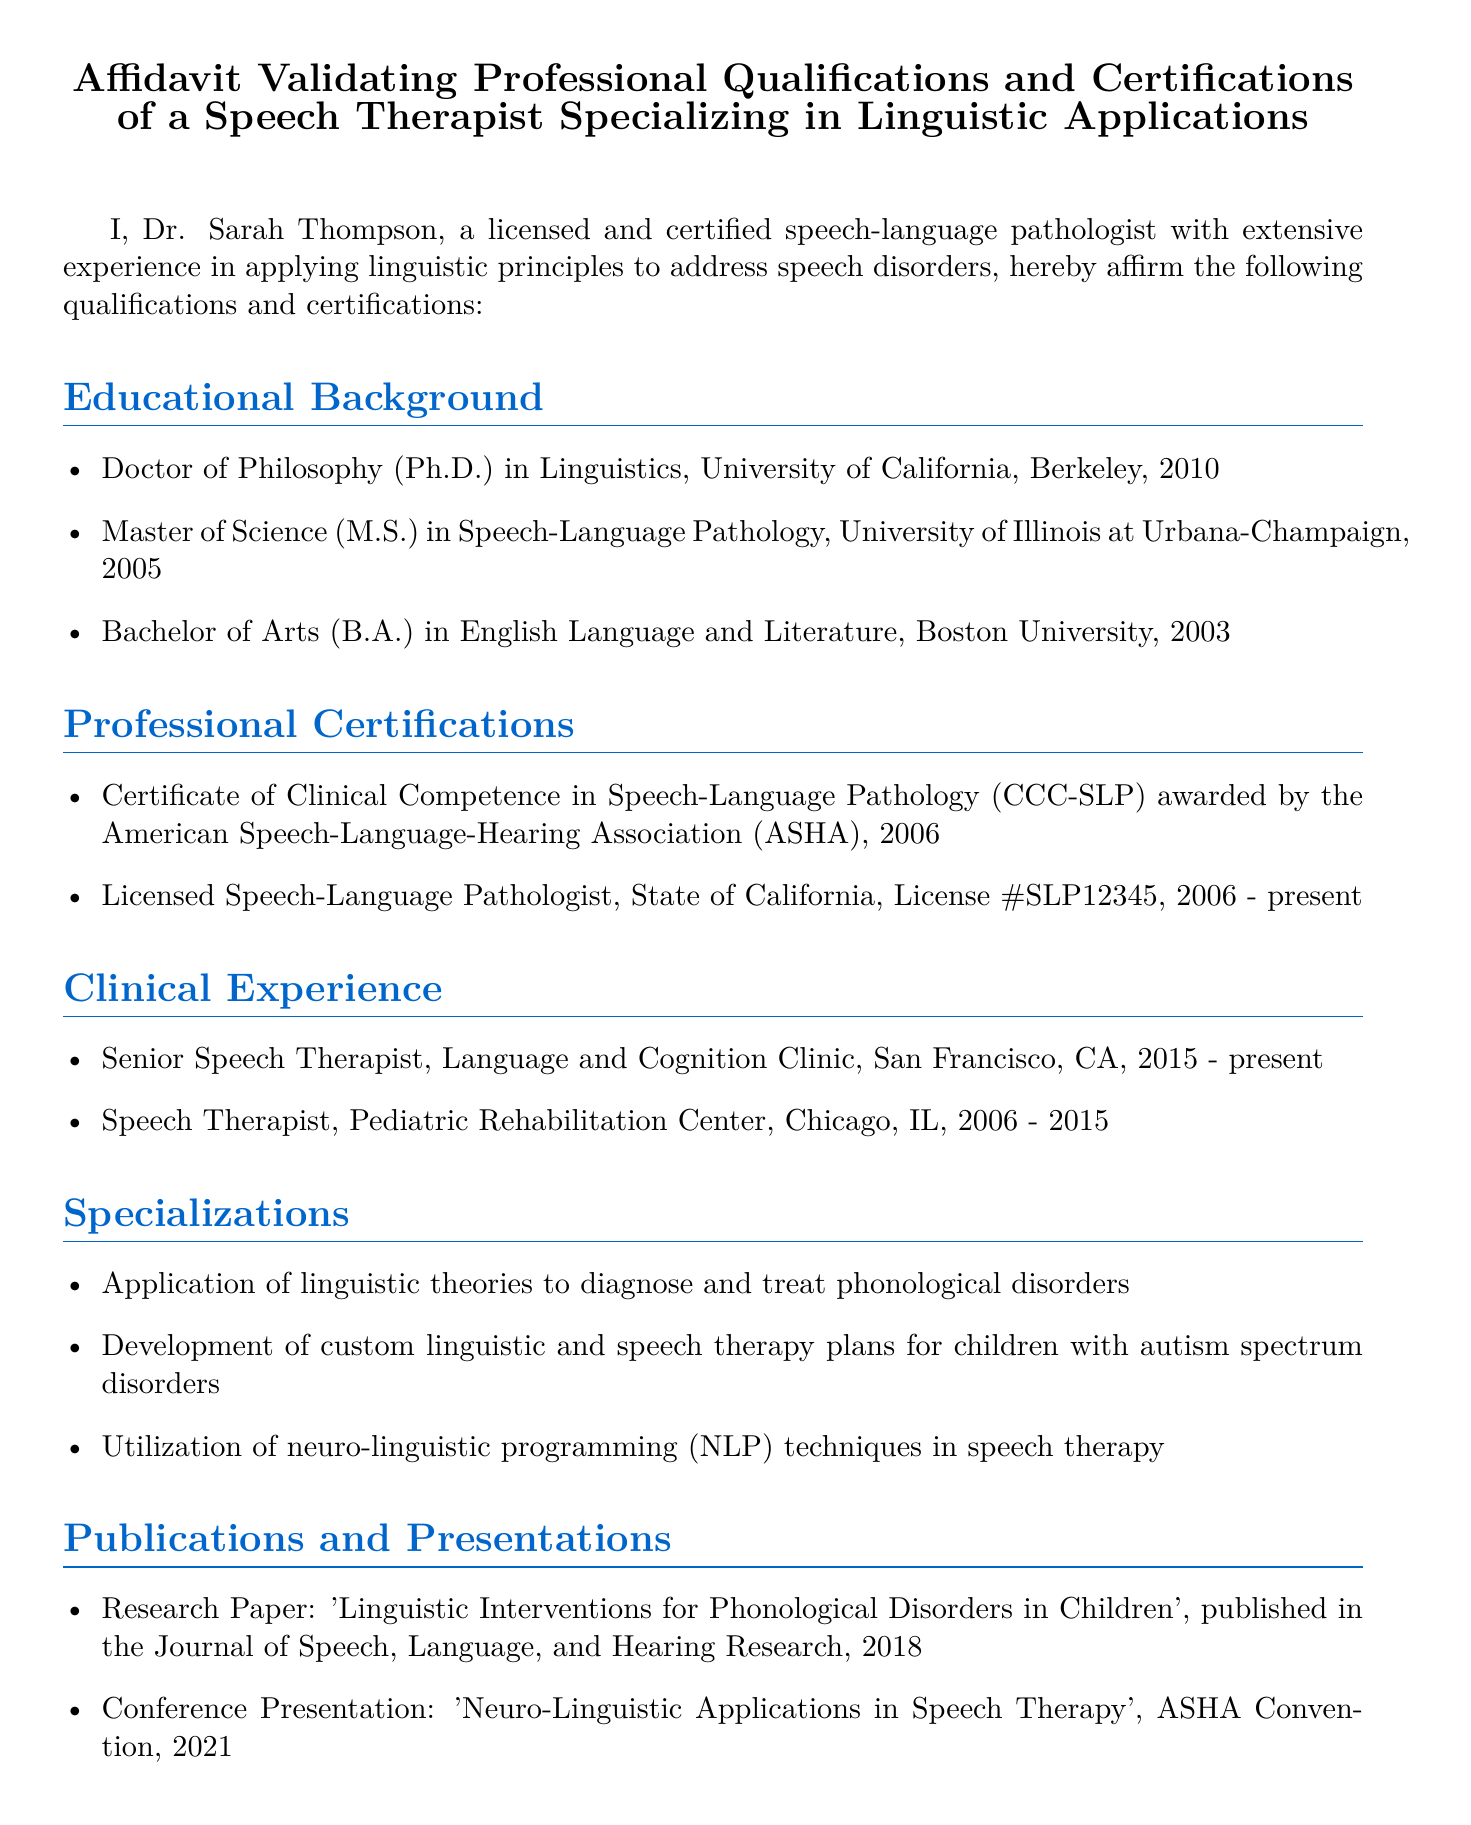What is the name of the speech therapist? The name is mentioned at the beginning of the affidavit, which states, "I, Dr. Sarah Thompson."
Answer: Dr. Sarah Thompson What year did Dr. Sarah Thompson receive her Ph.D. in Linguistics? The year is listed in the educational background section, specifically stating "University of California, Berkeley, 2010."
Answer: 2010 What certification was awarded by the American Speech-Language-Hearing Association? The certification is detailed under professional certifications, stating "Certificate of Clinical Competence in Speech-Language Pathology (CCC-SLP)."
Answer: CCC-SLP How many years of clinical experience does Dr. Sarah Thompson have? The years of experience are calculated based on the positions held, summing up from 2006 to the present (2023) equals 17 years.
Answer: 17 years What is one of Dr. Sarah Thompson's specializations? The specializations section directly lists areas of expertise, such as "Application of linguistic theories to diagnose and treat phonological disorders."
Answer: Phonological disorders What is the title of the research paper published in 2018? The title is provided in the publications section which states, "'Linguistic Interventions for Phonological Disorders in Children'."
Answer: Linguistic Interventions for Phonological Disorders in Children What role does Dr. Sarah Thompson currently hold? This information is found in the clinical experience section where it states, "Senior Speech Therapist, Language and Cognition Clinic."
Answer: Senior Speech Therapist In what state is Dr. Sarah Thompson licensed as a speech-language pathologist? The document notes her license specific to the state under professional certifications, which states "Licensed Speech-Language Pathologist, State of California."
Answer: California 